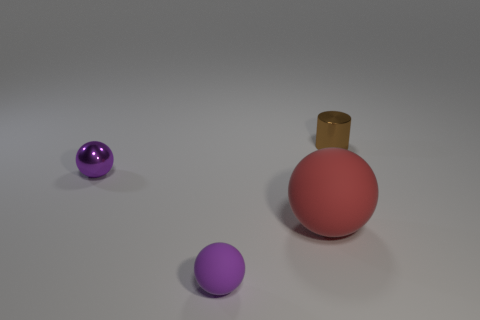Subtract all cyan cylinders. Subtract all red blocks. How many cylinders are left? 1 Add 4 small metal cylinders. How many objects exist? 8 Subtract all spheres. How many objects are left? 1 Subtract all large brown shiny cylinders. Subtract all red matte spheres. How many objects are left? 3 Add 4 tiny metal objects. How many tiny metal objects are left? 6 Add 1 rubber spheres. How many rubber spheres exist? 3 Subtract 0 yellow balls. How many objects are left? 4 